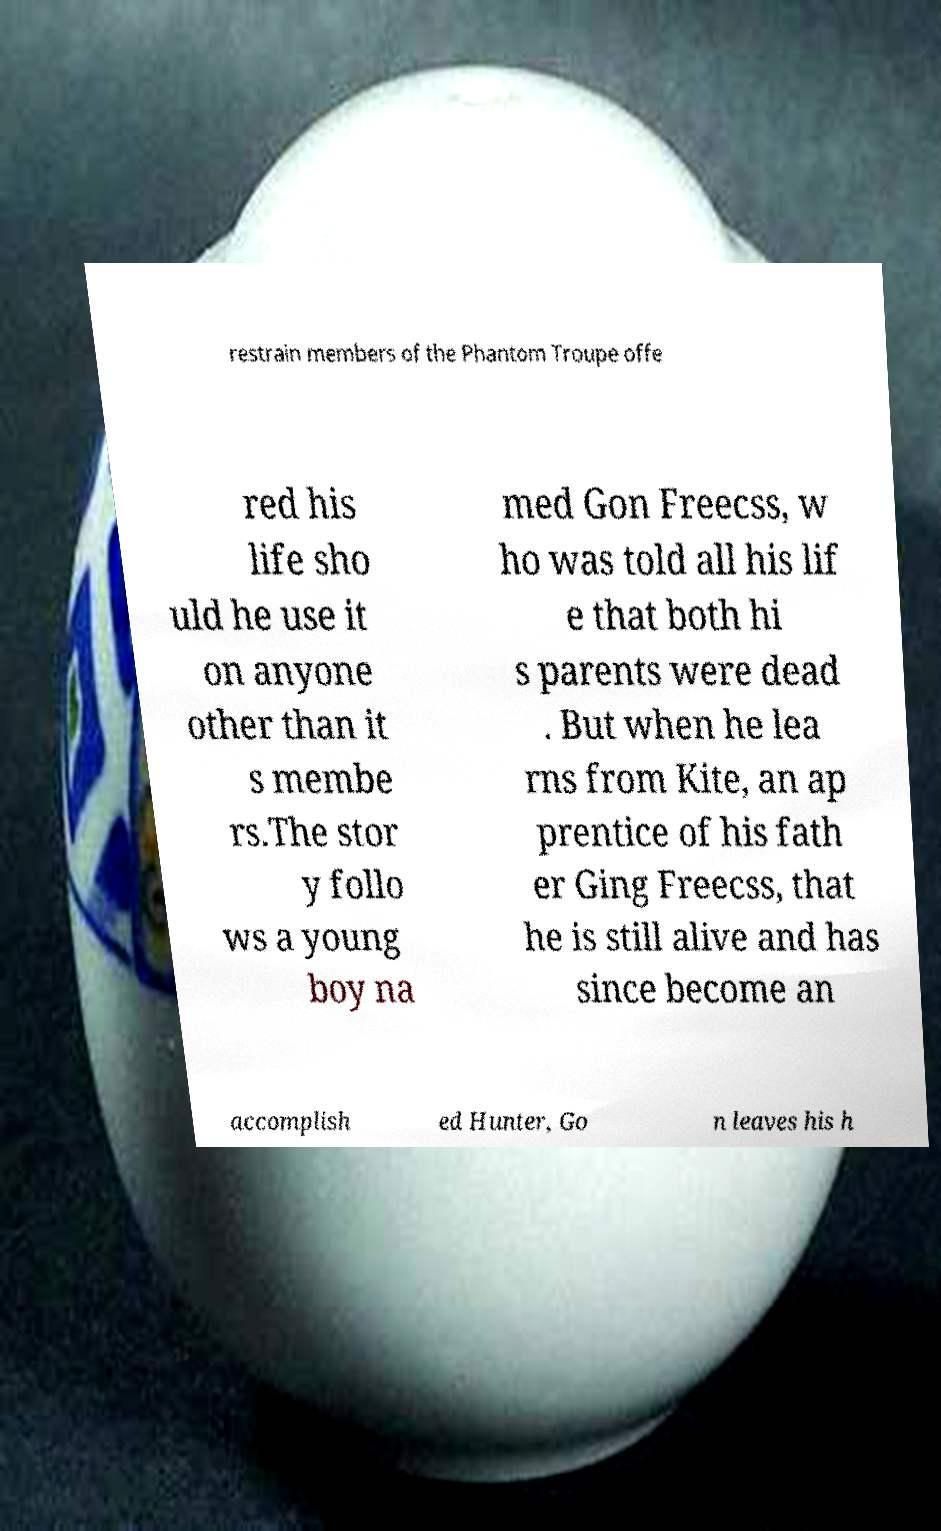Can you accurately transcribe the text from the provided image for me? restrain members of the Phantom Troupe offe red his life sho uld he use it on anyone other than it s membe rs.The stor y follo ws a young boy na med Gon Freecss, w ho was told all his lif e that both hi s parents were dead . But when he lea rns from Kite, an ap prentice of his fath er Ging Freecss, that he is still alive and has since become an accomplish ed Hunter, Go n leaves his h 